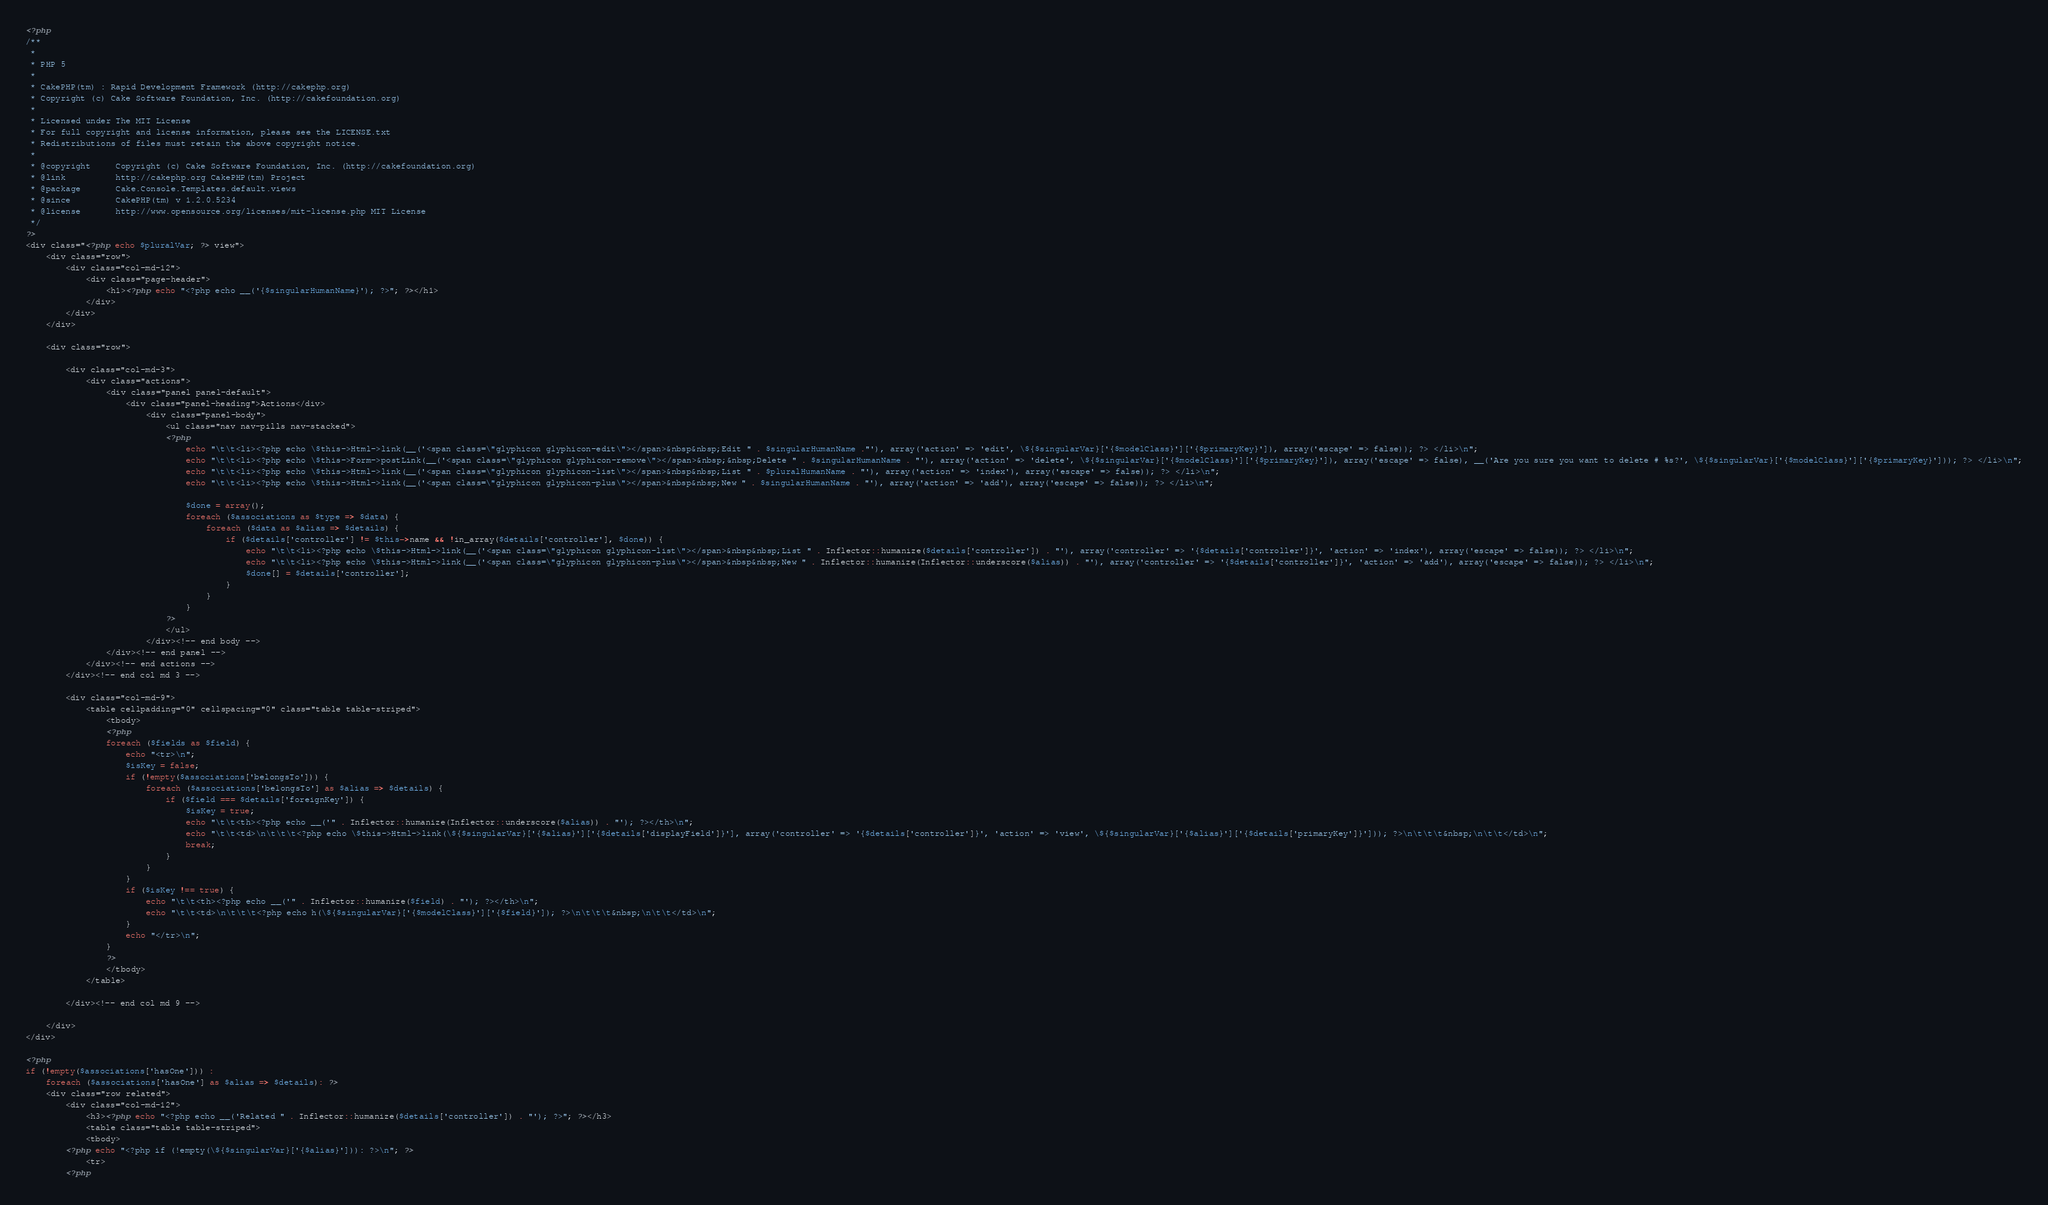<code> <loc_0><loc_0><loc_500><loc_500><_PHP_><?php
/**
 *
 * PHP 5
 *
 * CakePHP(tm) : Rapid Development Framework (http://cakephp.org)
 * Copyright (c) Cake Software Foundation, Inc. (http://cakefoundation.org)
 *
 * Licensed under The MIT License
 * For full copyright and license information, please see the LICENSE.txt
 * Redistributions of files must retain the above copyright notice.
 *
 * @copyright     Copyright (c) Cake Software Foundation, Inc. (http://cakefoundation.org)
 * @link          http://cakephp.org CakePHP(tm) Project
 * @package       Cake.Console.Templates.default.views
 * @since         CakePHP(tm) v 1.2.0.5234
 * @license       http://www.opensource.org/licenses/mit-license.php MIT License
 */
?>
<div class="<?php echo $pluralVar; ?> view">
	<div class="row">
		<div class="col-md-12">
			<div class="page-header">
				<h1><?php echo "<?php echo __('{$singularHumanName}'); ?>"; ?></h1>
			</div>
		</div>
	</div>

	<div class="row">

		<div class="col-md-3">
			<div class="actions">
				<div class="panel panel-default">
					<div class="panel-heading">Actions</div>
						<div class="panel-body">
							<ul class="nav nav-pills nav-stacked">
							<?php
								echo "\t\t<li><?php echo \$this->Html->link(__('<span class=\"glyphicon glyphicon-edit\"></span>&nbsp&nbsp;Edit " . $singularHumanName ."'), array('action' => 'edit', \${$singularVar}['{$modelClass}']['{$primaryKey}']), array('escape' => false)); ?> </li>\n";
								echo "\t\t<li><?php echo \$this->Form->postLink(__('<span class=\"glyphicon glyphicon-remove\"></span>&nbsp;&nbsp;Delete " . $singularHumanName . "'), array('action' => 'delete', \${$singularVar}['{$modelClass}']['{$primaryKey}']), array('escape' => false), __('Are you sure you want to delete # %s?', \${$singularVar}['{$modelClass}']['{$primaryKey}'])); ?> </li>\n";
								echo "\t\t<li><?php echo \$this->Html->link(__('<span class=\"glyphicon glyphicon-list\"></span>&nbsp&nbsp;List " . $pluralHumanName . "'), array('action' => 'index'), array('escape' => false)); ?> </li>\n";
								echo "\t\t<li><?php echo \$this->Html->link(__('<span class=\"glyphicon glyphicon-plus\"></span>&nbsp&nbsp;New " . $singularHumanName . "'), array('action' => 'add'), array('escape' => false)); ?> </li>\n";

								$done = array();
								foreach ($associations as $type => $data) {
									foreach ($data as $alias => $details) {
										if ($details['controller'] != $this->name && !in_array($details['controller'], $done)) {
											echo "\t\t<li><?php echo \$this->Html->link(__('<span class=\"glyphicon glyphicon-list\"></span>&nbsp&nbsp;List " . Inflector::humanize($details['controller']) . "'), array('controller' => '{$details['controller']}', 'action' => 'index'), array('escape' => false)); ?> </li>\n";
											echo "\t\t<li><?php echo \$this->Html->link(__('<span class=\"glyphicon glyphicon-plus\"></span>&nbsp&nbsp;New " . Inflector::humanize(Inflector::underscore($alias)) . "'), array('controller' => '{$details['controller']}', 'action' => 'add'), array('escape' => false)); ?> </li>\n";
											$done[] = $details['controller'];
										}
									}
								}
							?>
							</ul>
						</div><!-- end body -->
				</div><!-- end panel -->
			</div><!-- end actions -->
		</div><!-- end col md 3 -->

		<div class="col-md-9">			
			<table cellpadding="0" cellspacing="0" class="table table-striped">
				<tbody>
				<?php
				foreach ($fields as $field) {
					echo "<tr>\n";
					$isKey = false;
					if (!empty($associations['belongsTo'])) {
						foreach ($associations['belongsTo'] as $alias => $details) {
							if ($field === $details['foreignKey']) {
								$isKey = true;
								echo "\t\t<th><?php echo __('" . Inflector::humanize(Inflector::underscore($alias)) . "'); ?></th>\n";
								echo "\t\t<td>\n\t\t\t<?php echo \$this->Html->link(\${$singularVar}['{$alias}']['{$details['displayField']}'], array('controller' => '{$details['controller']}', 'action' => 'view', \${$singularVar}['{$alias}']['{$details['primaryKey']}'])); ?>\n\t\t\t&nbsp;\n\t\t</td>\n";
								break;
							}
						}
					}
					if ($isKey !== true) {
						echo "\t\t<th><?php echo __('" . Inflector::humanize($field) . "'); ?></th>\n";
						echo "\t\t<td>\n\t\t\t<?php echo h(\${$singularVar}['{$modelClass}']['{$field}']); ?>\n\t\t\t&nbsp;\n\t\t</td>\n";
					}
					echo "</tr>\n";
				}
				?>
				</tbody>
			</table>

		</div><!-- end col md 9 -->

	</div>
</div>

<?php
if (!empty($associations['hasOne'])) :
	foreach ($associations['hasOne'] as $alias => $details): ?>
	<div class="row related">
		<div class="col-md-12">
			<h3><?php echo "<?php echo __('Related " . Inflector::humanize($details['controller']) . "'); ?>"; ?></h3>
			<table class="table table-striped">
			<tbody>
		<?php echo "<?php if (!empty(\${$singularVar}['{$alias}'])): ?>\n"; ?>
			<tr>
		<?php</code> 